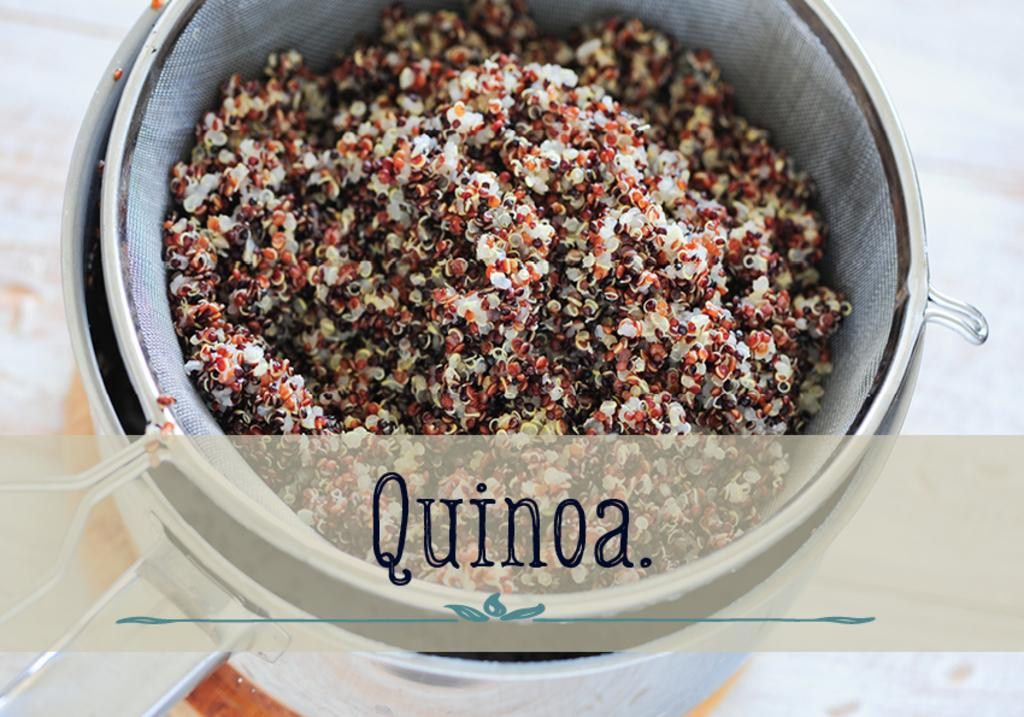What is inside the jar that is visible in the image? There is food in the jar. What else can be seen in the image besides the jar? There is text written on the image. What type of coil is used to power the trains in the image? There are no trains or coils present in the image; it only features a jar with food and text. 